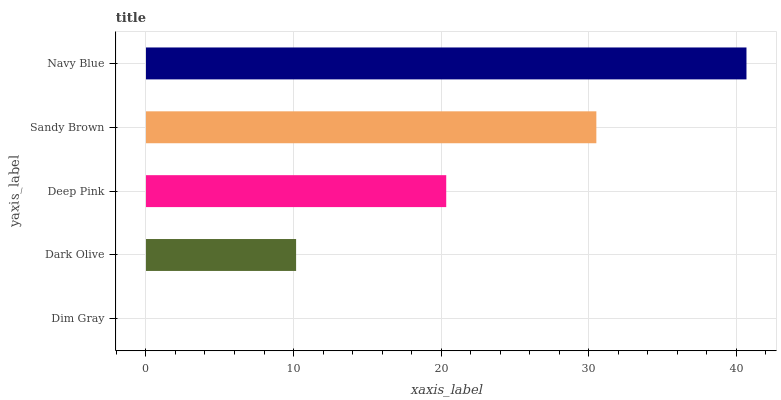Is Dim Gray the minimum?
Answer yes or no. Yes. Is Navy Blue the maximum?
Answer yes or no. Yes. Is Dark Olive the minimum?
Answer yes or no. No. Is Dark Olive the maximum?
Answer yes or no. No. Is Dark Olive greater than Dim Gray?
Answer yes or no. Yes. Is Dim Gray less than Dark Olive?
Answer yes or no. Yes. Is Dim Gray greater than Dark Olive?
Answer yes or no. No. Is Dark Olive less than Dim Gray?
Answer yes or no. No. Is Deep Pink the high median?
Answer yes or no. Yes. Is Deep Pink the low median?
Answer yes or no. Yes. Is Navy Blue the high median?
Answer yes or no. No. Is Navy Blue the low median?
Answer yes or no. No. 